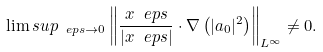Convert formula to latex. <formula><loc_0><loc_0><loc_500><loc_500>\lim s u p _ { \ e p s \to 0 } \left \| \frac { x ^ { \ } e p s } { | x ^ { \ } e p s | } \cdot \nabla \left ( | a _ { 0 } | ^ { 2 } \right ) \right \| _ { L ^ { \infty } } \not = 0 .</formula> 